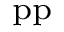Convert formula to latex. <formula><loc_0><loc_0><loc_500><loc_500>_ { p } p</formula> 